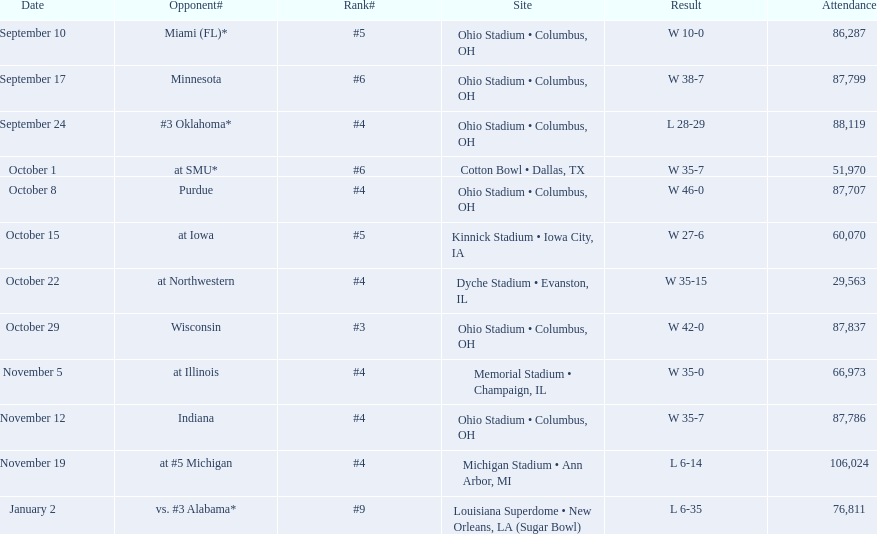What is the difference between the number of wins and the number of losses? 6. Can you give me this table as a dict? {'header': ['Date', 'Opponent#', 'Rank#', 'Site', 'Result', 'Attendance'], 'rows': [['September 10', 'Miami (FL)*', '#5', 'Ohio Stadium • Columbus, OH', 'W\xa010-0', '86,287'], ['September 17', 'Minnesota', '#6', 'Ohio Stadium • Columbus, OH', 'W\xa038-7', '87,799'], ['September 24', '#3\xa0Oklahoma*', '#4', 'Ohio Stadium • Columbus, OH', 'L\xa028-29', '88,119'], ['October 1', 'at\xa0SMU*', '#6', 'Cotton Bowl • Dallas, TX', 'W\xa035-7', '51,970'], ['October 8', 'Purdue', '#4', 'Ohio Stadium • Columbus, OH', 'W\xa046-0', '87,707'], ['October 15', 'at\xa0Iowa', '#5', 'Kinnick Stadium • Iowa City, IA', 'W\xa027-6', '60,070'], ['October 22', 'at\xa0Northwestern', '#4', 'Dyche Stadium • Evanston, IL', 'W\xa035-15', '29,563'], ['October 29', 'Wisconsin', '#3', 'Ohio Stadium • Columbus, OH', 'W\xa042-0', '87,837'], ['November 5', 'at\xa0Illinois', '#4', 'Memorial Stadium • Champaign, IL', 'W\xa035-0', '66,973'], ['November 12', 'Indiana', '#4', 'Ohio Stadium • Columbus, OH', 'W\xa035-7', '87,786'], ['November 19', 'at\xa0#5\xa0Michigan', '#4', 'Michigan Stadium • Ann Arbor, MI', 'L\xa06-14', '106,024'], ['January 2', 'vs.\xa0#3\xa0Alabama*', '#9', 'Louisiana Superdome • New Orleans, LA (Sugar Bowl)', 'L\xa06-35', '76,811']]} 